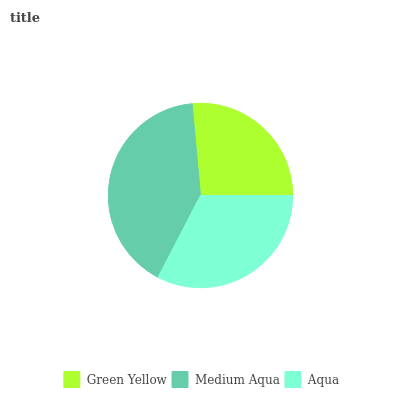Is Green Yellow the minimum?
Answer yes or no. Yes. Is Medium Aqua the maximum?
Answer yes or no. Yes. Is Aqua the minimum?
Answer yes or no. No. Is Aqua the maximum?
Answer yes or no. No. Is Medium Aqua greater than Aqua?
Answer yes or no. Yes. Is Aqua less than Medium Aqua?
Answer yes or no. Yes. Is Aqua greater than Medium Aqua?
Answer yes or no. No. Is Medium Aqua less than Aqua?
Answer yes or no. No. Is Aqua the high median?
Answer yes or no. Yes. Is Aqua the low median?
Answer yes or no. Yes. Is Medium Aqua the high median?
Answer yes or no. No. Is Medium Aqua the low median?
Answer yes or no. No. 